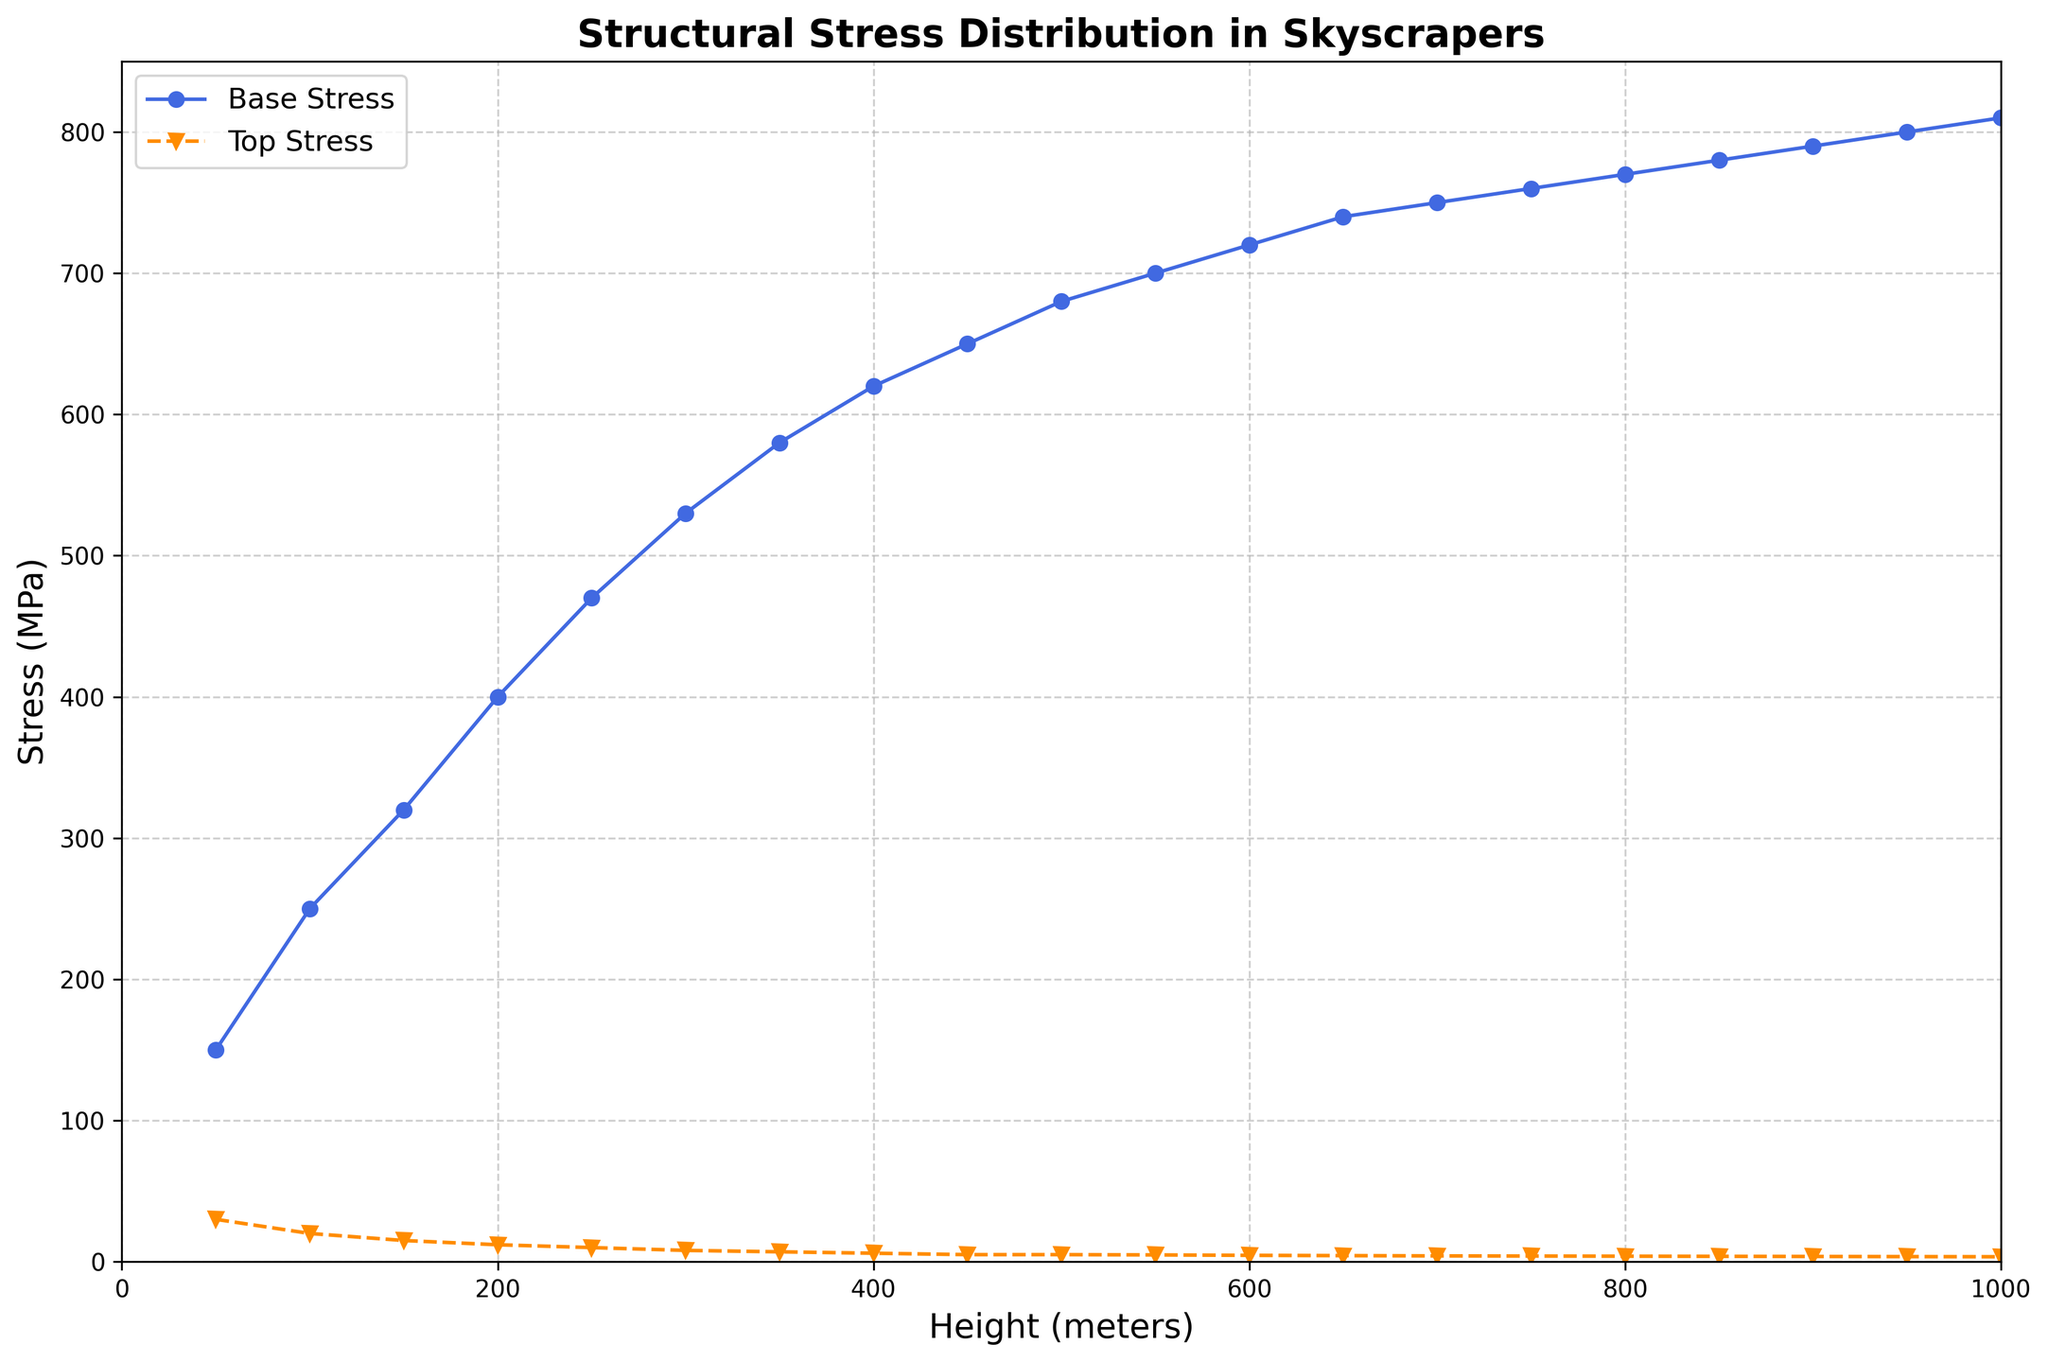What is the stress at the top of the skyscraper when the height is 600 meters? Look at the data point that corresponds to a height of 600 meters on the x-axis, then move vertically to the 'Top Stress' line and read the value on the y-axis.
Answer: 4.5 MPa What is the difference in base stress between skyscrapers of 500 meters and 1000 meters in height? Identify the base stress values at 500 meters and 1000 meters from the 'Base Stress' line, which are 680 MPa and 810 MPa respectively. Then, compute the difference: 810 - 680.
Answer: 130 MPa How does the base stress compare to the top stress as the height of the skyscraper increases? Notice the trend lines for both Base and Top Stress. Base Stress shows a general increasing trend with height, while Top Stress shows a decreasing trend. A detailed look reveals that the base stress increases significantly as height increases, whereas the top stress decreases at a slower rate.
Answer: Base stress increases, top stress decreases At what height do the base and top stress levels have the maximum difference? Analyze the vertical difference between the two curves on the plot. The maximum difference appears where the vertical gap between 'Base Stress' and 'Top Stress' is largest. This visual gap seems largest around the height of 50 meters.
Answer: 50 meters What is the average top stress in the height range from 900 to 1000 meters? Locate the top stress values at heights of 900 and 1000 meters, which are 3.7 MPa and 3.5 MPa respectively. Add these values (3.7 + 3.5) and divide by the number of points (2).
Answer: 3.6 MPa Compare the slopes of the base stress increase and top stress decrease between 200 and 400 meters. Which changes more rapidly? Calculate the slope for each segment in the specified range. For base stress from 200 to 400 meters: (620 - 400) / (400 - 200) = 220/200 = 1.1. For top stress from 200 to 400 meters: (6 - 12) / (400 - 200) = -6/200 = -0.03. The base stress increases more rapidly.
Answer: Base stress changes more rapidly What is the top stress decrease from 50 meters to 300 meters? Identify the top stress values at 50 meters (30 MPa) and 300 meters (8 MPa). Compute the difference: 30 - 8.
Answer: 22 MPa Does the base stress at 700 meters exceed the base stress at 100 meters? By how much? Compare the base stress values at 700 meters (750 MPa) and 100 meters (250 MPa) and calculate the difference: 750 - 250.
Answer: Yes, by 500 MPa What is the trend in stress distribution observed on the figure? Observe the plotted lines. The base stress trendline shows an upward trajectory over the height range, while the top stress trendline shows a downward trajectory.
Answer: Base stress increases, top stress decreases 